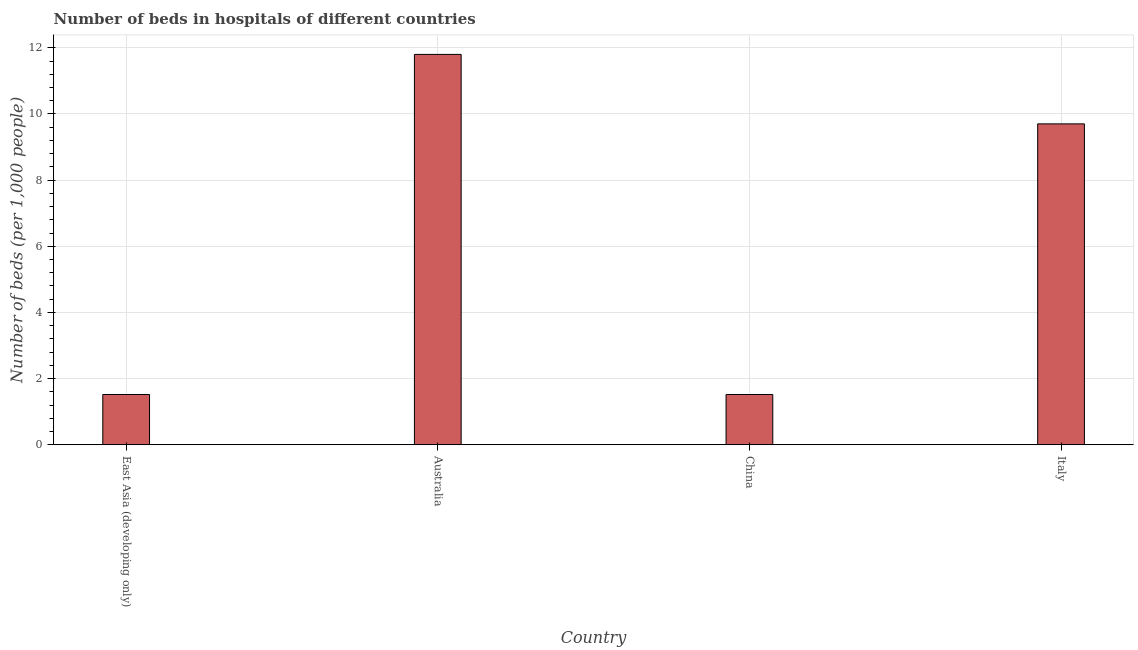What is the title of the graph?
Make the answer very short. Number of beds in hospitals of different countries. What is the label or title of the X-axis?
Keep it short and to the point. Country. What is the label or title of the Y-axis?
Give a very brief answer. Number of beds (per 1,0 people). What is the number of hospital beds in China?
Give a very brief answer. 1.52. Across all countries, what is the maximum number of hospital beds?
Your answer should be very brief. 11.8. Across all countries, what is the minimum number of hospital beds?
Your answer should be compact. 1.52. In which country was the number of hospital beds minimum?
Provide a succinct answer. East Asia (developing only). What is the sum of the number of hospital beds?
Provide a succinct answer. 24.54. What is the difference between the number of hospital beds in China and East Asia (developing only)?
Offer a very short reply. 0. What is the average number of hospital beds per country?
Provide a short and direct response. 6.13. What is the median number of hospital beds?
Your answer should be compact. 5.61. What is the ratio of the number of hospital beds in East Asia (developing only) to that in Italy?
Provide a succinct answer. 0.16. Is the number of hospital beds in Australia less than that in Italy?
Offer a very short reply. No. What is the difference between the highest and the second highest number of hospital beds?
Make the answer very short. 2.1. Is the sum of the number of hospital beds in China and Italy greater than the maximum number of hospital beds across all countries?
Offer a terse response. No. What is the difference between the highest and the lowest number of hospital beds?
Make the answer very short. 10.28. How many bars are there?
Your answer should be compact. 4. How many countries are there in the graph?
Offer a terse response. 4. What is the difference between two consecutive major ticks on the Y-axis?
Provide a short and direct response. 2. What is the Number of beds (per 1,000 people) of East Asia (developing only)?
Provide a succinct answer. 1.52. What is the Number of beds (per 1,000 people) in Australia?
Your response must be concise. 11.8. What is the Number of beds (per 1,000 people) in China?
Ensure brevity in your answer.  1.52. What is the Number of beds (per 1,000 people) in Italy?
Give a very brief answer. 9.7. What is the difference between the Number of beds (per 1,000 people) in East Asia (developing only) and Australia?
Offer a terse response. -10.28. What is the difference between the Number of beds (per 1,000 people) in East Asia (developing only) and Italy?
Offer a terse response. -8.18. What is the difference between the Number of beds (per 1,000 people) in Australia and China?
Your response must be concise. 10.28. What is the difference between the Number of beds (per 1,000 people) in Australia and Italy?
Give a very brief answer. 2.1. What is the difference between the Number of beds (per 1,000 people) in China and Italy?
Offer a terse response. -8.18. What is the ratio of the Number of beds (per 1,000 people) in East Asia (developing only) to that in Australia?
Ensure brevity in your answer.  0.13. What is the ratio of the Number of beds (per 1,000 people) in East Asia (developing only) to that in Italy?
Your answer should be compact. 0.16. What is the ratio of the Number of beds (per 1,000 people) in Australia to that in China?
Give a very brief answer. 7.76. What is the ratio of the Number of beds (per 1,000 people) in Australia to that in Italy?
Your answer should be compact. 1.22. What is the ratio of the Number of beds (per 1,000 people) in China to that in Italy?
Your response must be concise. 0.16. 